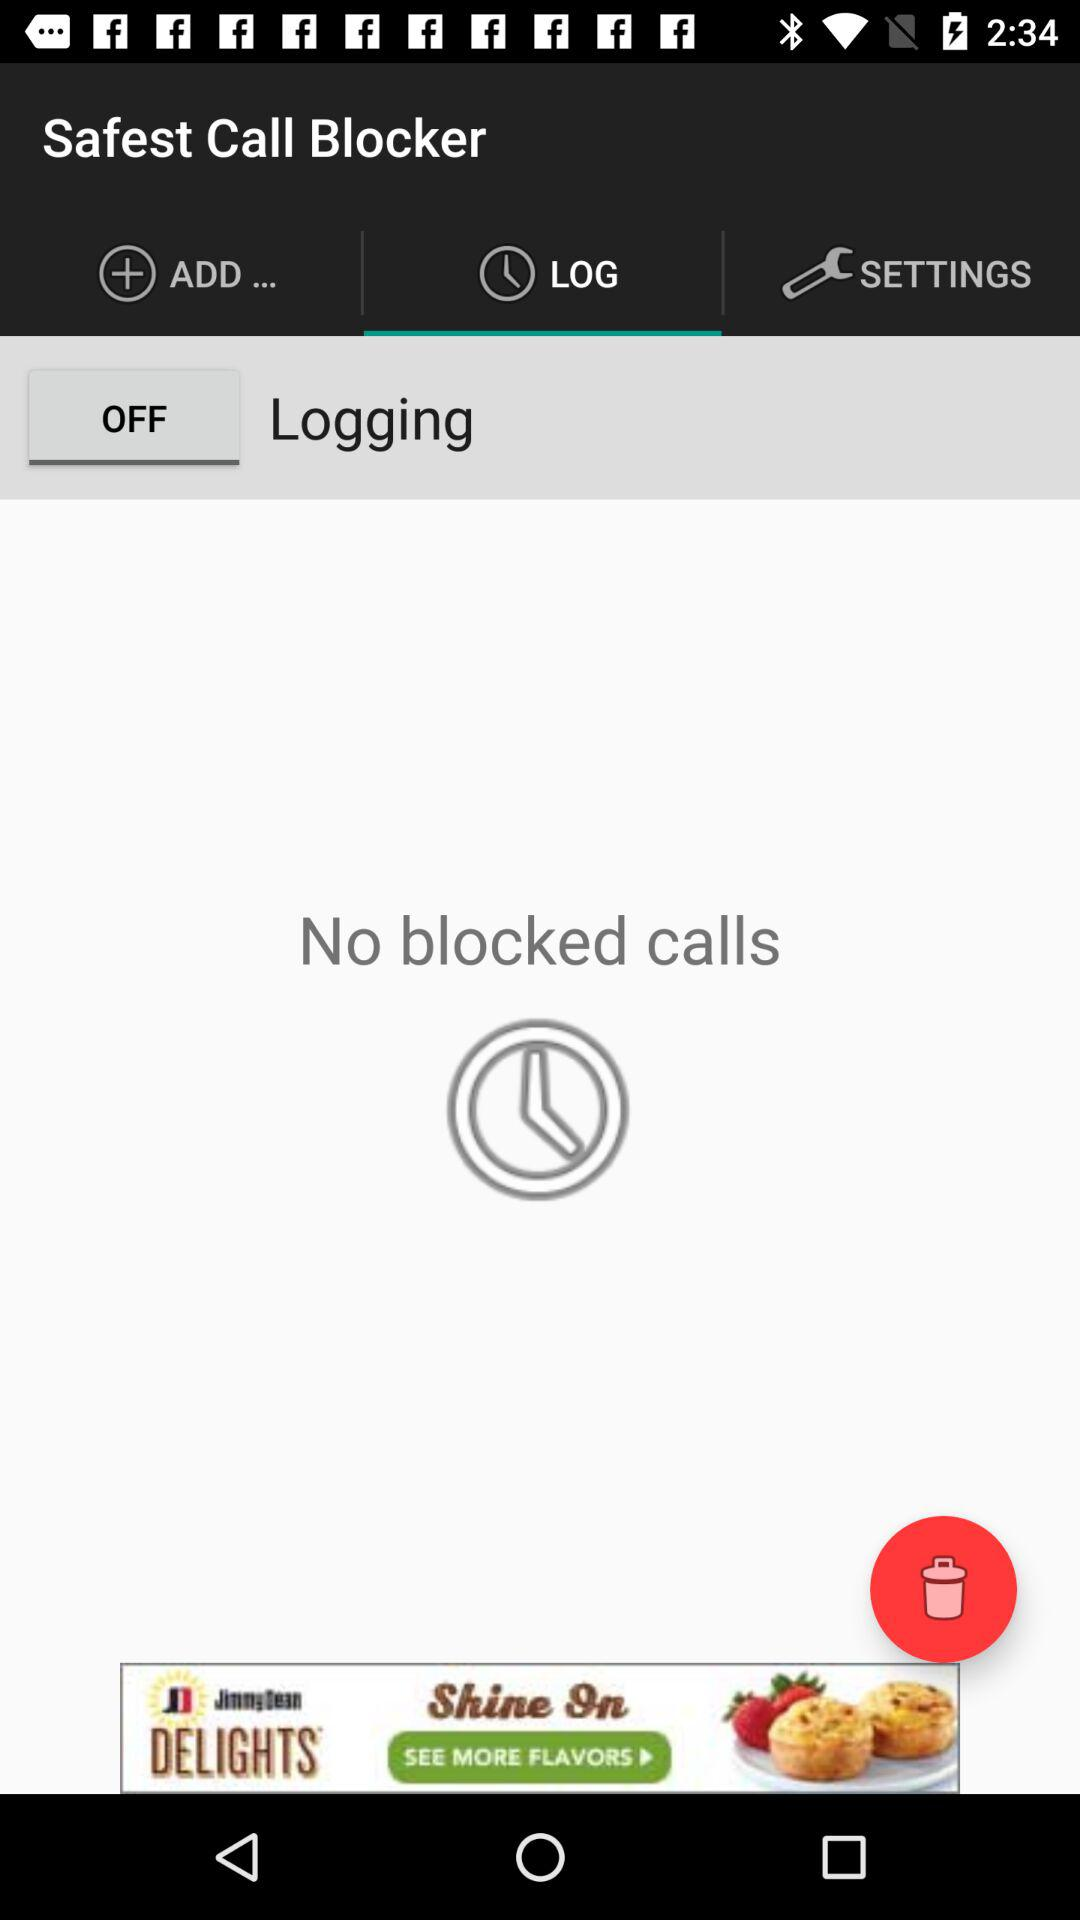Which tab is selected? The selected tab is "LOG". 